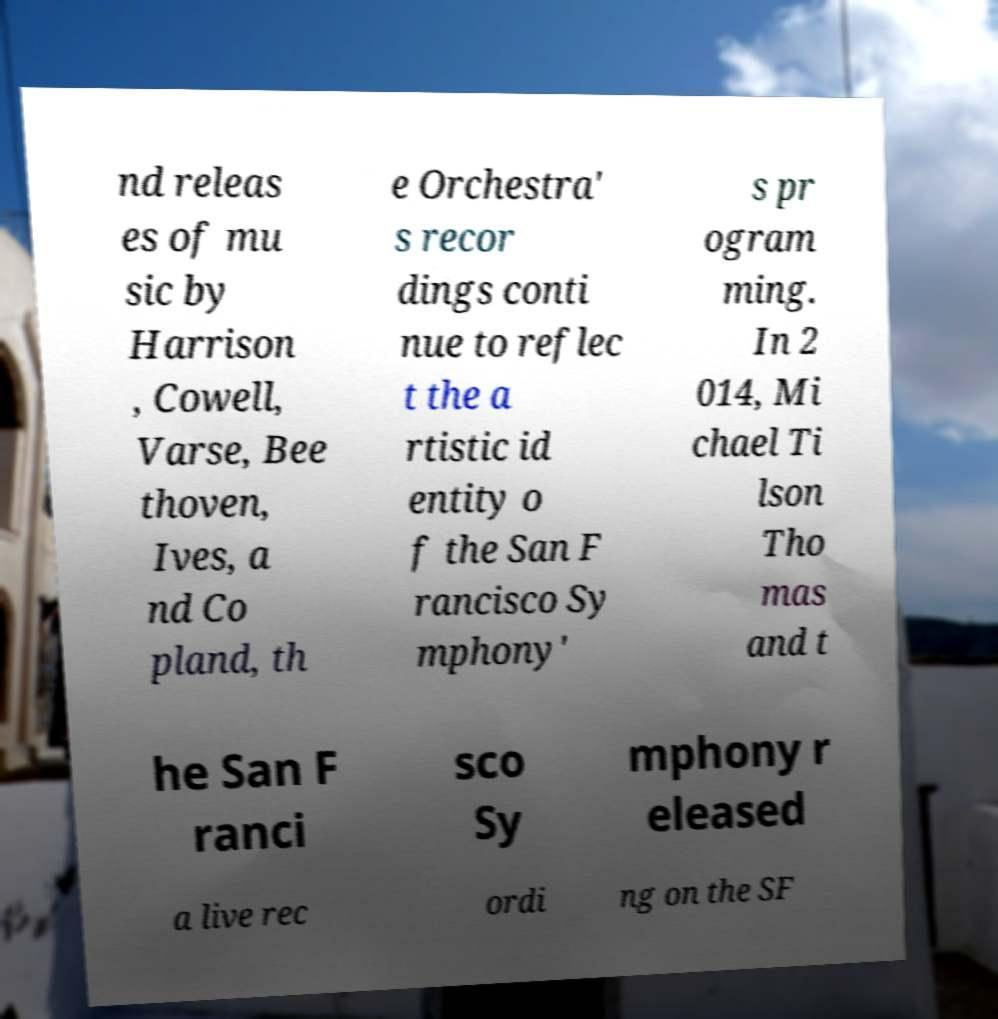For documentation purposes, I need the text within this image transcribed. Could you provide that? nd releas es of mu sic by Harrison , Cowell, Varse, Bee thoven, Ives, a nd Co pland, th e Orchestra' s recor dings conti nue to reflec t the a rtistic id entity o f the San F rancisco Sy mphony' s pr ogram ming. In 2 014, Mi chael Ti lson Tho mas and t he San F ranci sco Sy mphony r eleased a live rec ordi ng on the SF 